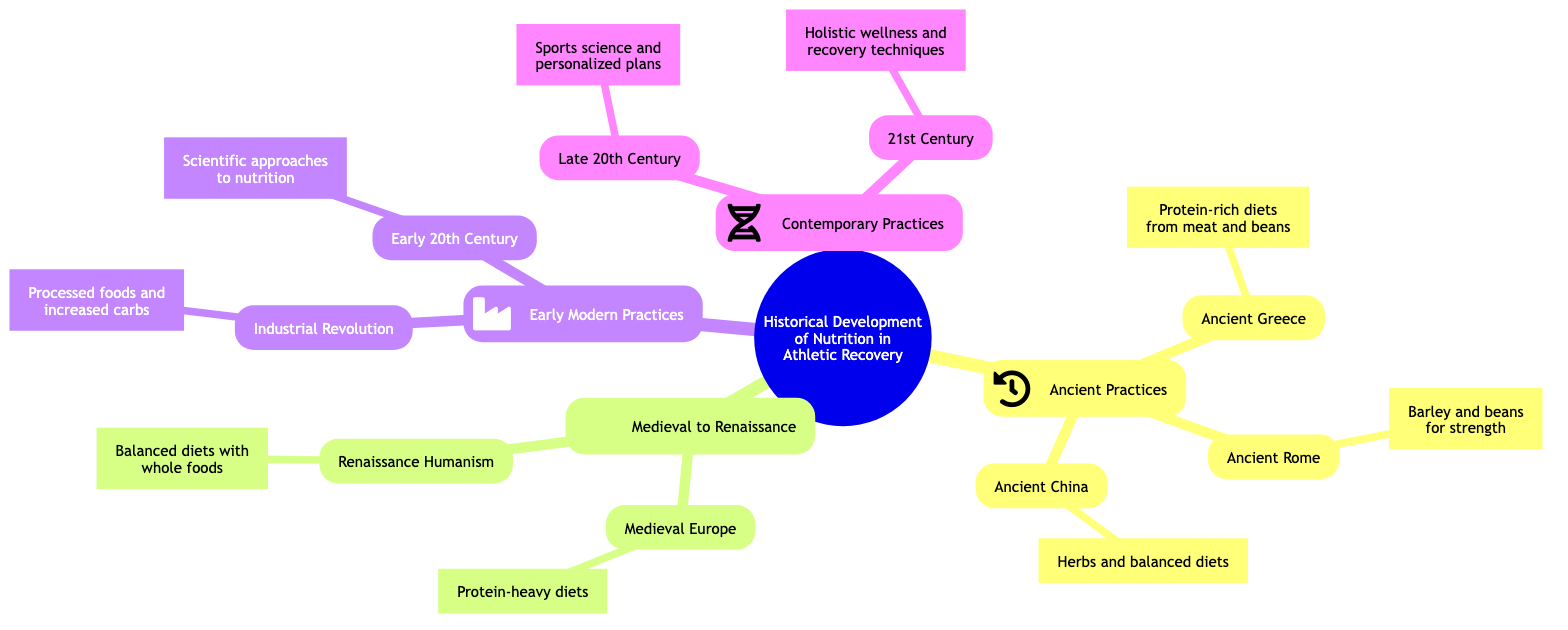What are the ancient practices of nutrition in athletic recovery? The diagram indicates that the ancient practices include Ancient Greece, Ancient Rome, and Ancient China. These are categorized under the first node, which is "Ancient Practices."
Answer: Ancient Greece, Ancient Rome, Ancient China How many elements are under Early Modern Practices? The section for Early Modern Practices consists of two elements: Industrial Revolution and Early 20th Century, as listed directly under this category in the diagram.
Answer: 2 Which ancient civilization focused on protein-rich diets primarily from meat and beans? Referring to the Ancient Practices category, the specific entry for Ancient Greece highlights that their athletes consumed diets rich in protein from meat and beans.
Answer: Ancient Greece What shift occurred during the Renaissance Humanism in nutrition practices? The diagram states that during Renaissance Humanism, there was a focus on balanced diets that drew from a variety of food sources, emphasizing whole grains, fruits, and vegetables, indicating a significant transition in dietary focus.
Answer: Balanced diets with whole foods How did nutritional practices change from the Industrial Revolution to the Early 20th Century? The diagram outlines that during the Industrial Revolution, there was an introduction of processed foods and increased carbohydrate consumption. This changed in the Early 20th Century when there was a rise in scientific approaches focusing on caloric intake and macronutrients, indicating a movement towards a more scientific understanding of nutrition.
Answer: From processed foods to scientific approaches What is the main emphasis in the 21st Century regarding nutrition in athletic recovery? In the diagram, the 21st Century is described as having an emphasis on holistic wellness, including organic foods, supplements, and specific recovery techniques, which indicates a comprehensive approach to athlete nutrition.
Answer: Holistic wellness and recovery techniques Which era is characterized by the integration of sports science in nutritional practices? The diagram specifies that the Late 20th Century signifies the integration of sports science into nutrition, which corresponds to a significant development in how athletes personalize their nutrition plans based on individual needs.
Answer: Late 20th Century How are medieval European diets described in the context of athletic recovery? According to the diagram's details under Medieval to Renaissance Practices, medieval European diets are characterized as protein-heavy, primarily consisting of meats and dairy, which were critical for knights and soldiers engaged in physically demanding activities.
Answer: Protein-heavy diets What detailed elements are present in the Industrial Revolution's nutritional changes? The diagram mentions that during the Industrial Revolution, there was an introduction of processed foods and an increase in carbohydrate consumption, highlighting a transition in dietary trends among athletes.
Answer: Processed foods and increased carbs 